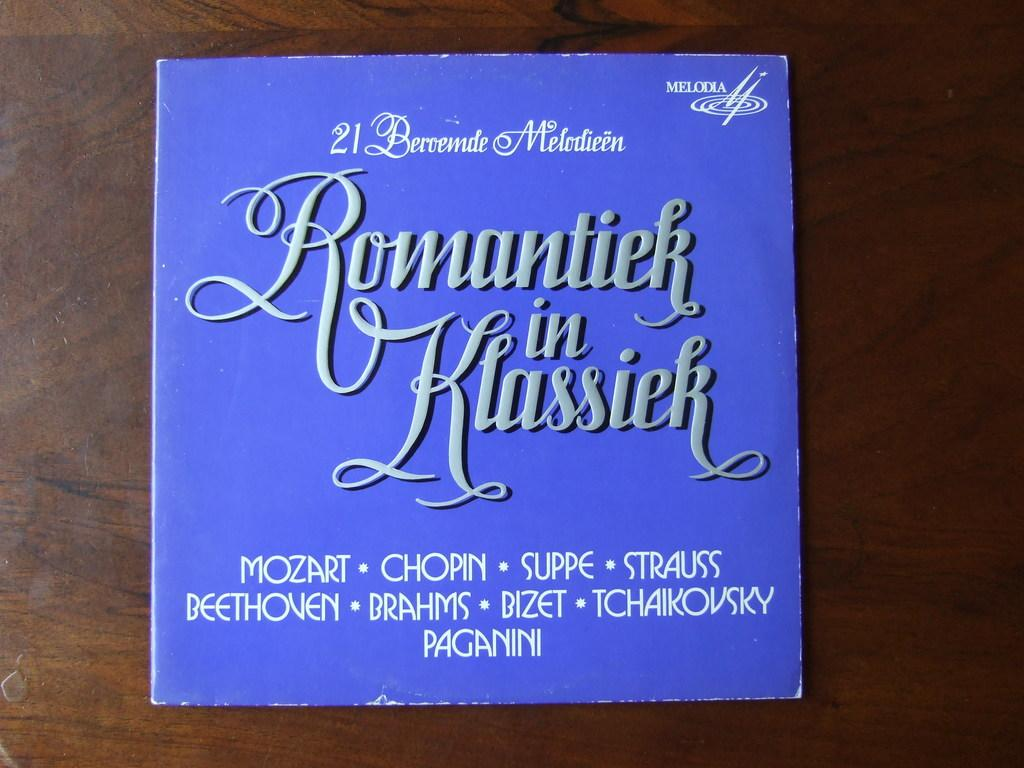<image>
Write a terse but informative summary of the picture. A record entitled Romantiek in Klassiek which features Mozart, Chopin, Suppe and other artists. 